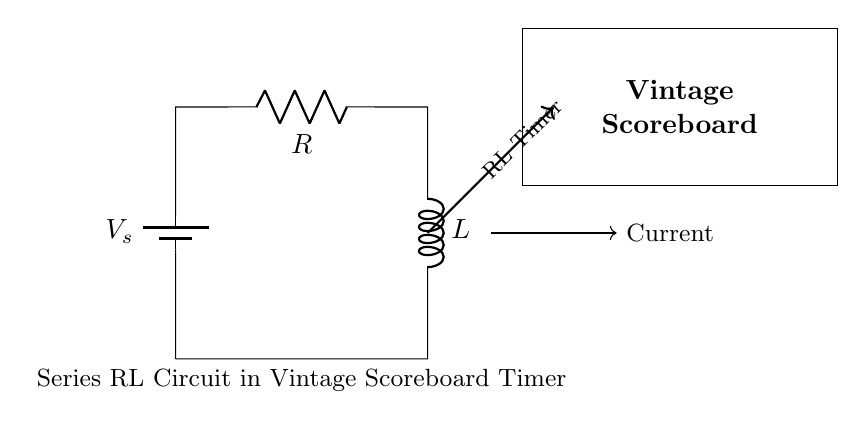What is the battery voltage in the circuit? The battery voltage is labeled as V_s in the diagram, which represents the supply voltage.
Answer: V_s What type of components are present in the circuit? The components shown in the circuit are a battery, a resistor, and an inductor, indicating it's a series RL circuit.
Answer: Battery, Resistor, Inductor What is the function of the RL timer in this circuit? The RL timer, indicated in the diagram, is used for timing purposes in the vintage scoreboard, controlling how long a display remains active or timing game events.
Answer: Timing How does the current flow in this series RL circuit? In a series circuit, the current flows through each component sequentially; hence, the same current flows through the resistor and the inductor.
Answer: Sequentially What happens to the current when the voltage is applied? When the voltage is applied, the current begins to rise, but it lags behind the voltage due to the inductive reactance of the inductor.
Answer: It lags What is the significance of the resistor in this circuit? The resistor limits the current flow and controls the damping effect, affecting how quickly the current reaches its steady state in the RL circuit.
Answer: Current limitation What occurs in an RL circuit when the power is turned off? When the power is turned off, the inductor will oppose changes in current and will continue to drive the current for a brief period due to stored energy.
Answer: Current continues briefly 